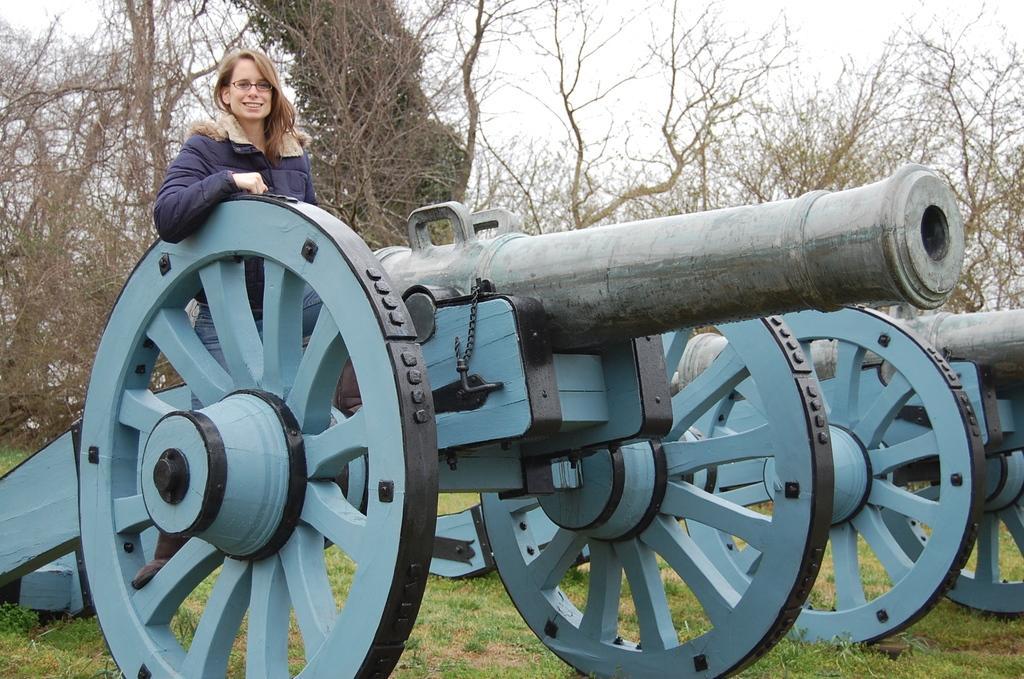Can you describe this image briefly? In this picture we can see cannons on the grass and on a cannon we can see a woman wore spectacles and smiling and in the background we can see trees and the sky. 